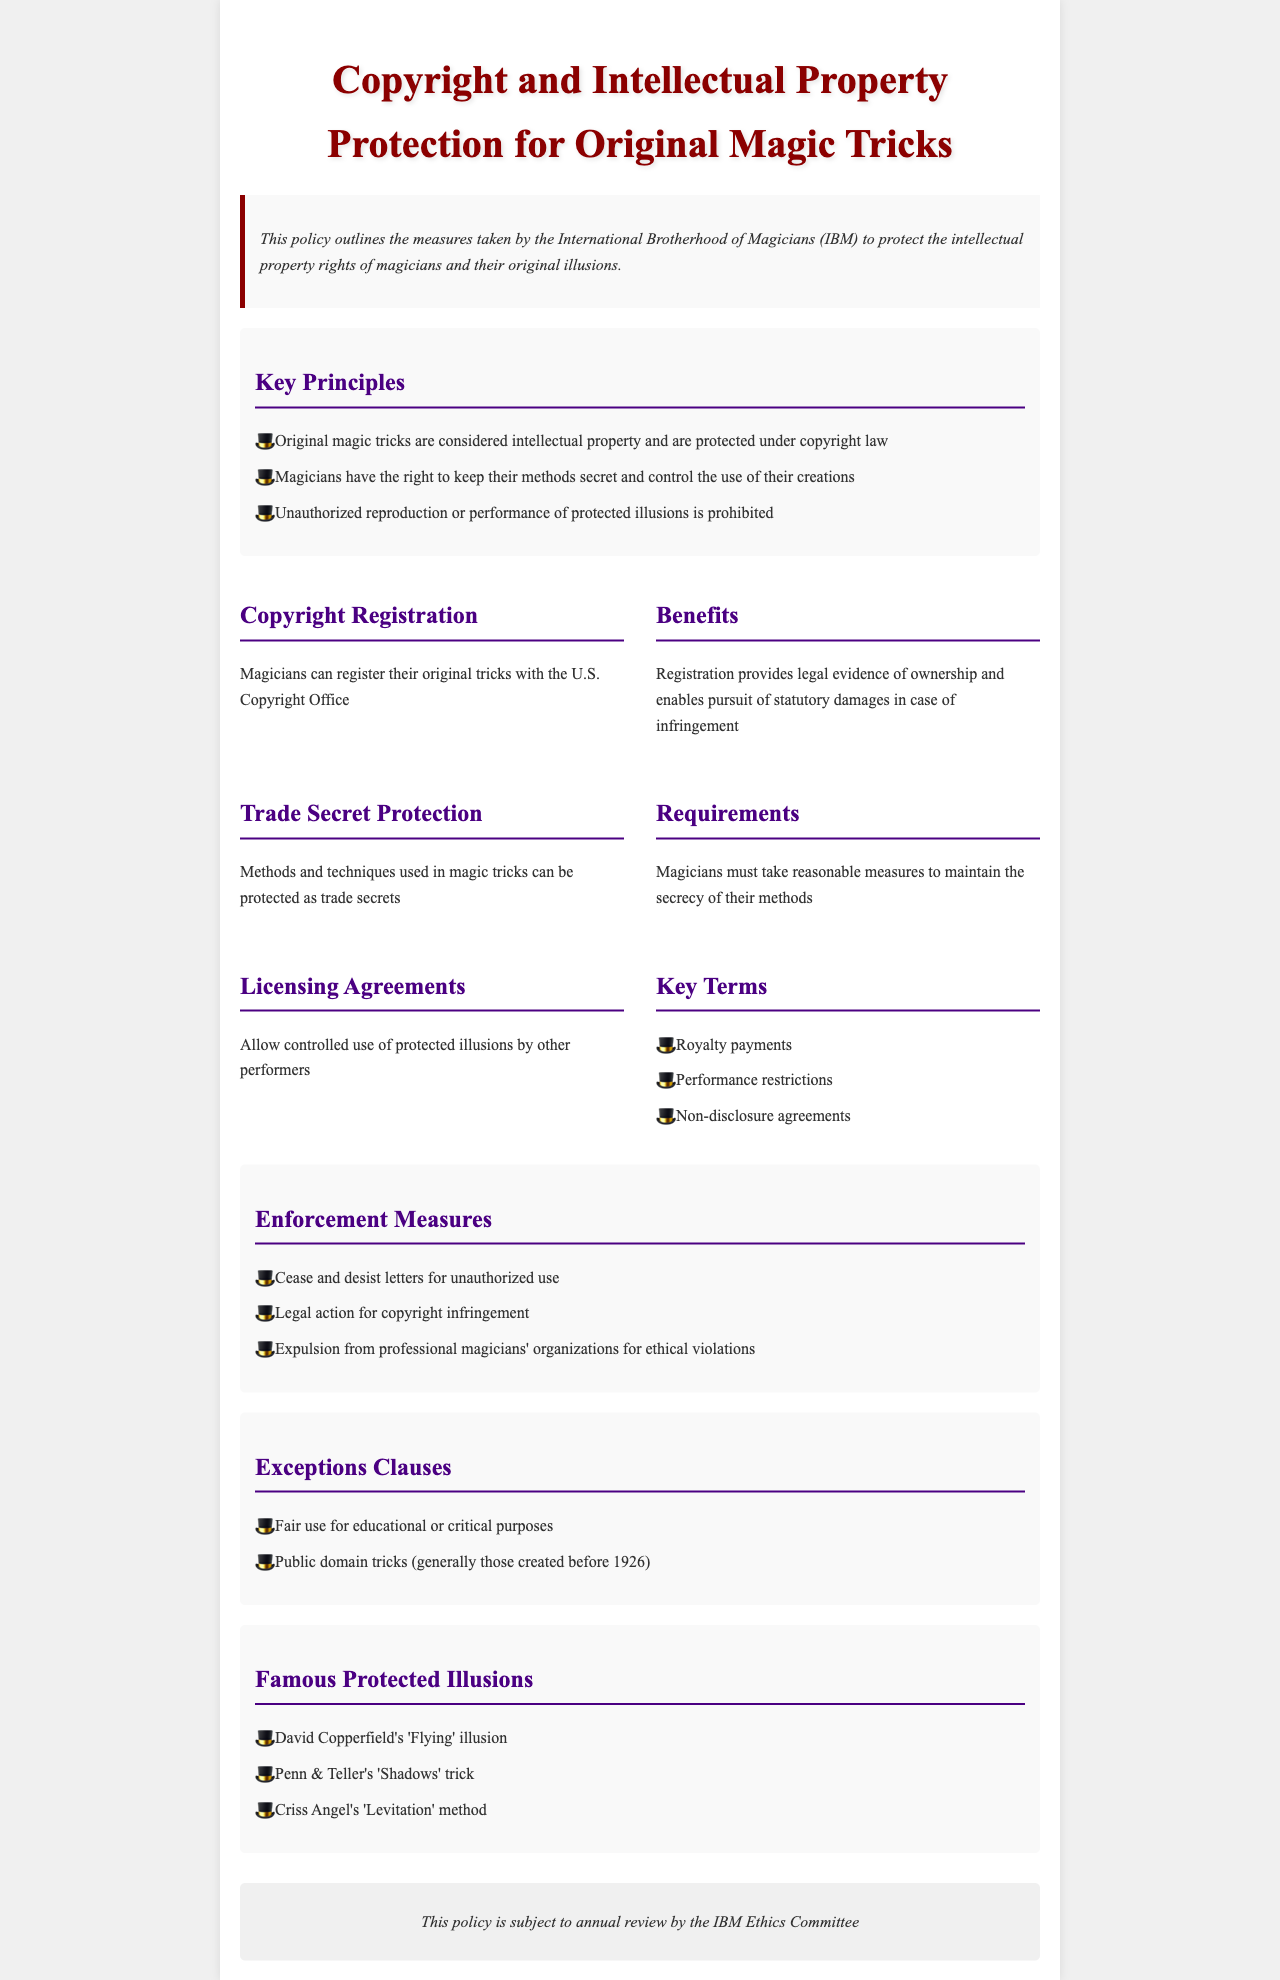What is the title of the document? The title is found in the header section and states the purpose of the policy.
Answer: Copyright and Intellectual Property Protection for Original Magic Tricks Who is the policy intended to protect? The document outlines the measures for a specific group in the magic community.
Answer: Magicians What does registration with the U.S. Copyright Office provide? The document lists the benefits of registration, including legal evidence.
Answer: Legal evidence of ownership What is one of the requirements for trade secret protection? The policy states a critical element for maintaining trade secret status.
Answer: Reasonable measures to maintain secrecy What kind of letters are used for unauthorized use enforcement? The document specifies a type of legal notification used in enforcement.
Answer: Cease and desist letters How often is the policy reviewed? The review frequency is mentioned in the concluding section of the document.
Answer: Annually What is a key term in licensing agreements? The document lists terms related to licensing, highlighting various aspects of agreements.
Answer: Royalty payments Name one famous protected illusion mentioned in the document. The document lists specific illusions that are protected by copyright.
Answer: David Copperfield's 'Flying' illusion 